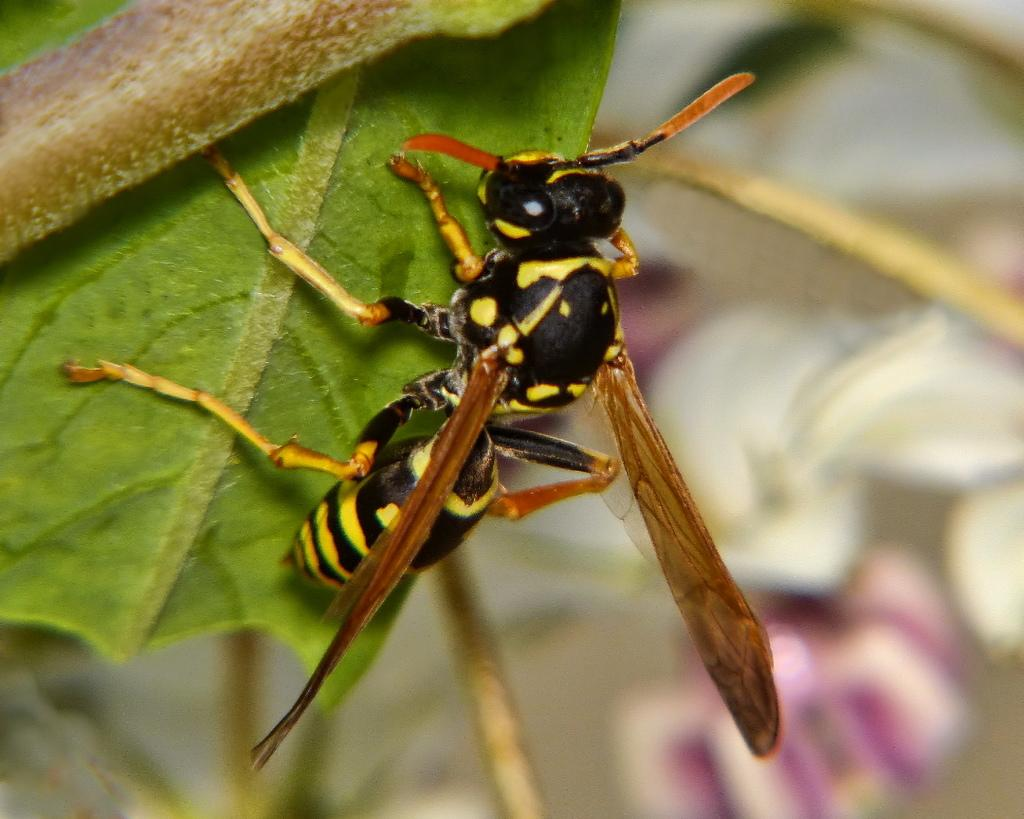What type of creature is present in the image? There is an insect in the image. What is the insect resting on? The insect is laying on a leaf. How is the background of the image depicted? The background of the insect is blurred. What type of berry is the insect eating in the image? There is no berry present in the image; the insect is laying on a leaf. 